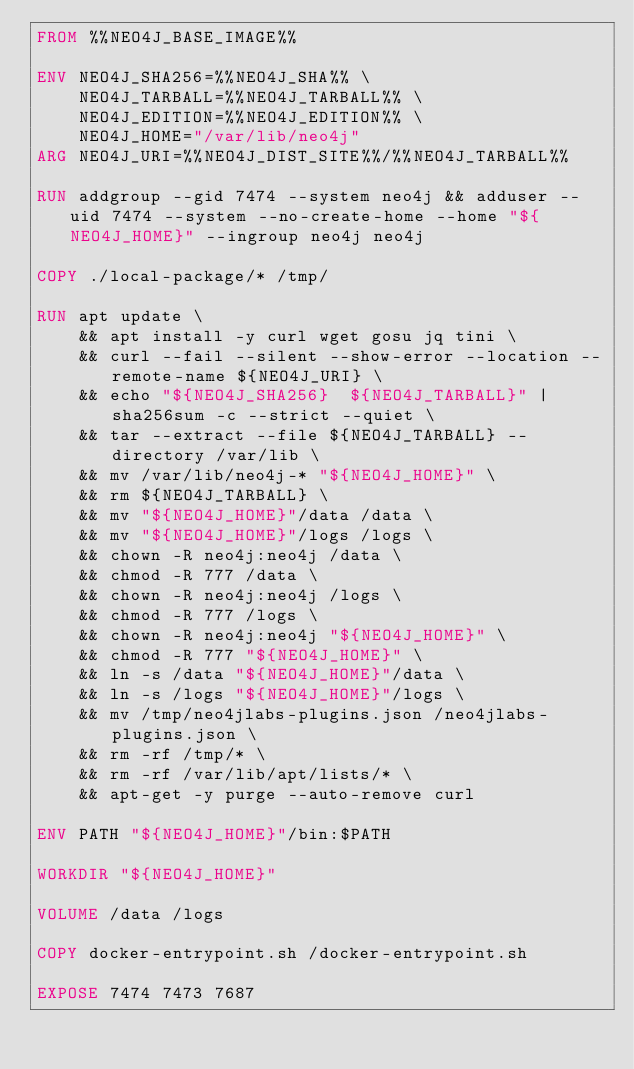<code> <loc_0><loc_0><loc_500><loc_500><_Dockerfile_>FROM %%NEO4J_BASE_IMAGE%%

ENV NEO4J_SHA256=%%NEO4J_SHA%% \
    NEO4J_TARBALL=%%NEO4J_TARBALL%% \
    NEO4J_EDITION=%%NEO4J_EDITION%% \
    NEO4J_HOME="/var/lib/neo4j"
ARG NEO4J_URI=%%NEO4J_DIST_SITE%%/%%NEO4J_TARBALL%%

RUN addgroup --gid 7474 --system neo4j && adduser --uid 7474 --system --no-create-home --home "${NEO4J_HOME}" --ingroup neo4j neo4j

COPY ./local-package/* /tmp/

RUN apt update \
    && apt install -y curl wget gosu jq tini \
    && curl --fail --silent --show-error --location --remote-name ${NEO4J_URI} \
    && echo "${NEO4J_SHA256}  ${NEO4J_TARBALL}" | sha256sum -c --strict --quiet \
    && tar --extract --file ${NEO4J_TARBALL} --directory /var/lib \
    && mv /var/lib/neo4j-* "${NEO4J_HOME}" \
    && rm ${NEO4J_TARBALL} \
    && mv "${NEO4J_HOME}"/data /data \
    && mv "${NEO4J_HOME}"/logs /logs \
    && chown -R neo4j:neo4j /data \
    && chmod -R 777 /data \
    && chown -R neo4j:neo4j /logs \
    && chmod -R 777 /logs \
    && chown -R neo4j:neo4j "${NEO4J_HOME}" \
    && chmod -R 777 "${NEO4J_HOME}" \
    && ln -s /data "${NEO4J_HOME}"/data \
    && ln -s /logs "${NEO4J_HOME}"/logs \
    && mv /tmp/neo4jlabs-plugins.json /neo4jlabs-plugins.json \
    && rm -rf /tmp/* \
    && rm -rf /var/lib/apt/lists/* \
    && apt-get -y purge --auto-remove curl

ENV PATH "${NEO4J_HOME}"/bin:$PATH

WORKDIR "${NEO4J_HOME}"

VOLUME /data /logs

COPY docker-entrypoint.sh /docker-entrypoint.sh

EXPOSE 7474 7473 7687
</code> 